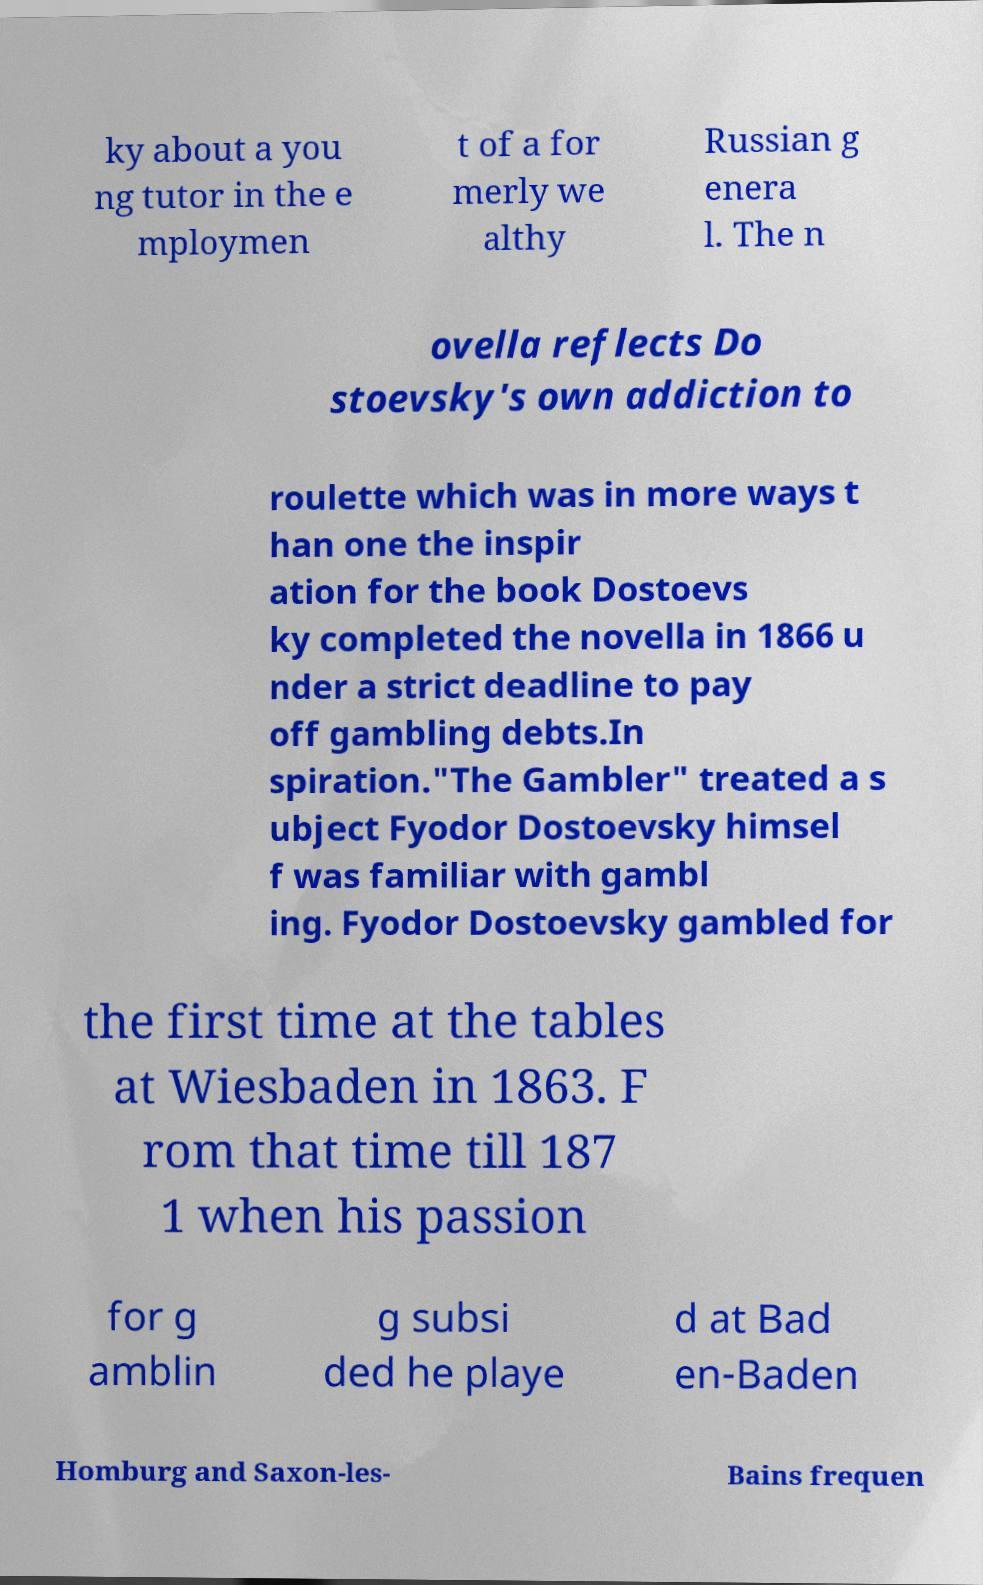I need the written content from this picture converted into text. Can you do that? ky about a you ng tutor in the e mploymen t of a for merly we althy Russian g enera l. The n ovella reflects Do stoevsky's own addiction to roulette which was in more ways t han one the inspir ation for the book Dostoevs ky completed the novella in 1866 u nder a strict deadline to pay off gambling debts.In spiration."The Gambler" treated a s ubject Fyodor Dostoevsky himsel f was familiar with gambl ing. Fyodor Dostoevsky gambled for the first time at the tables at Wiesbaden in 1863. F rom that time till 187 1 when his passion for g amblin g subsi ded he playe d at Bad en-Baden Homburg and Saxon-les- Bains frequen 